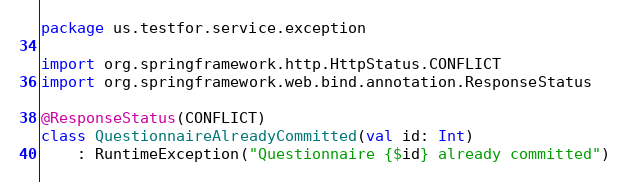<code> <loc_0><loc_0><loc_500><loc_500><_Kotlin_>package us.testfor.service.exception

import org.springframework.http.HttpStatus.CONFLICT
import org.springframework.web.bind.annotation.ResponseStatus

@ResponseStatus(CONFLICT)
class QuestionnaireAlreadyCommitted(val id: Int)
    : RuntimeException("Questionnaire {$id} already committed")
</code> 